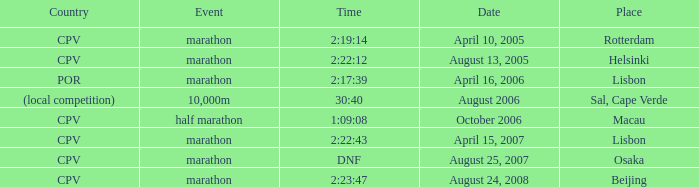What is the Place of the Event on August 25, 2007? Osaka. 